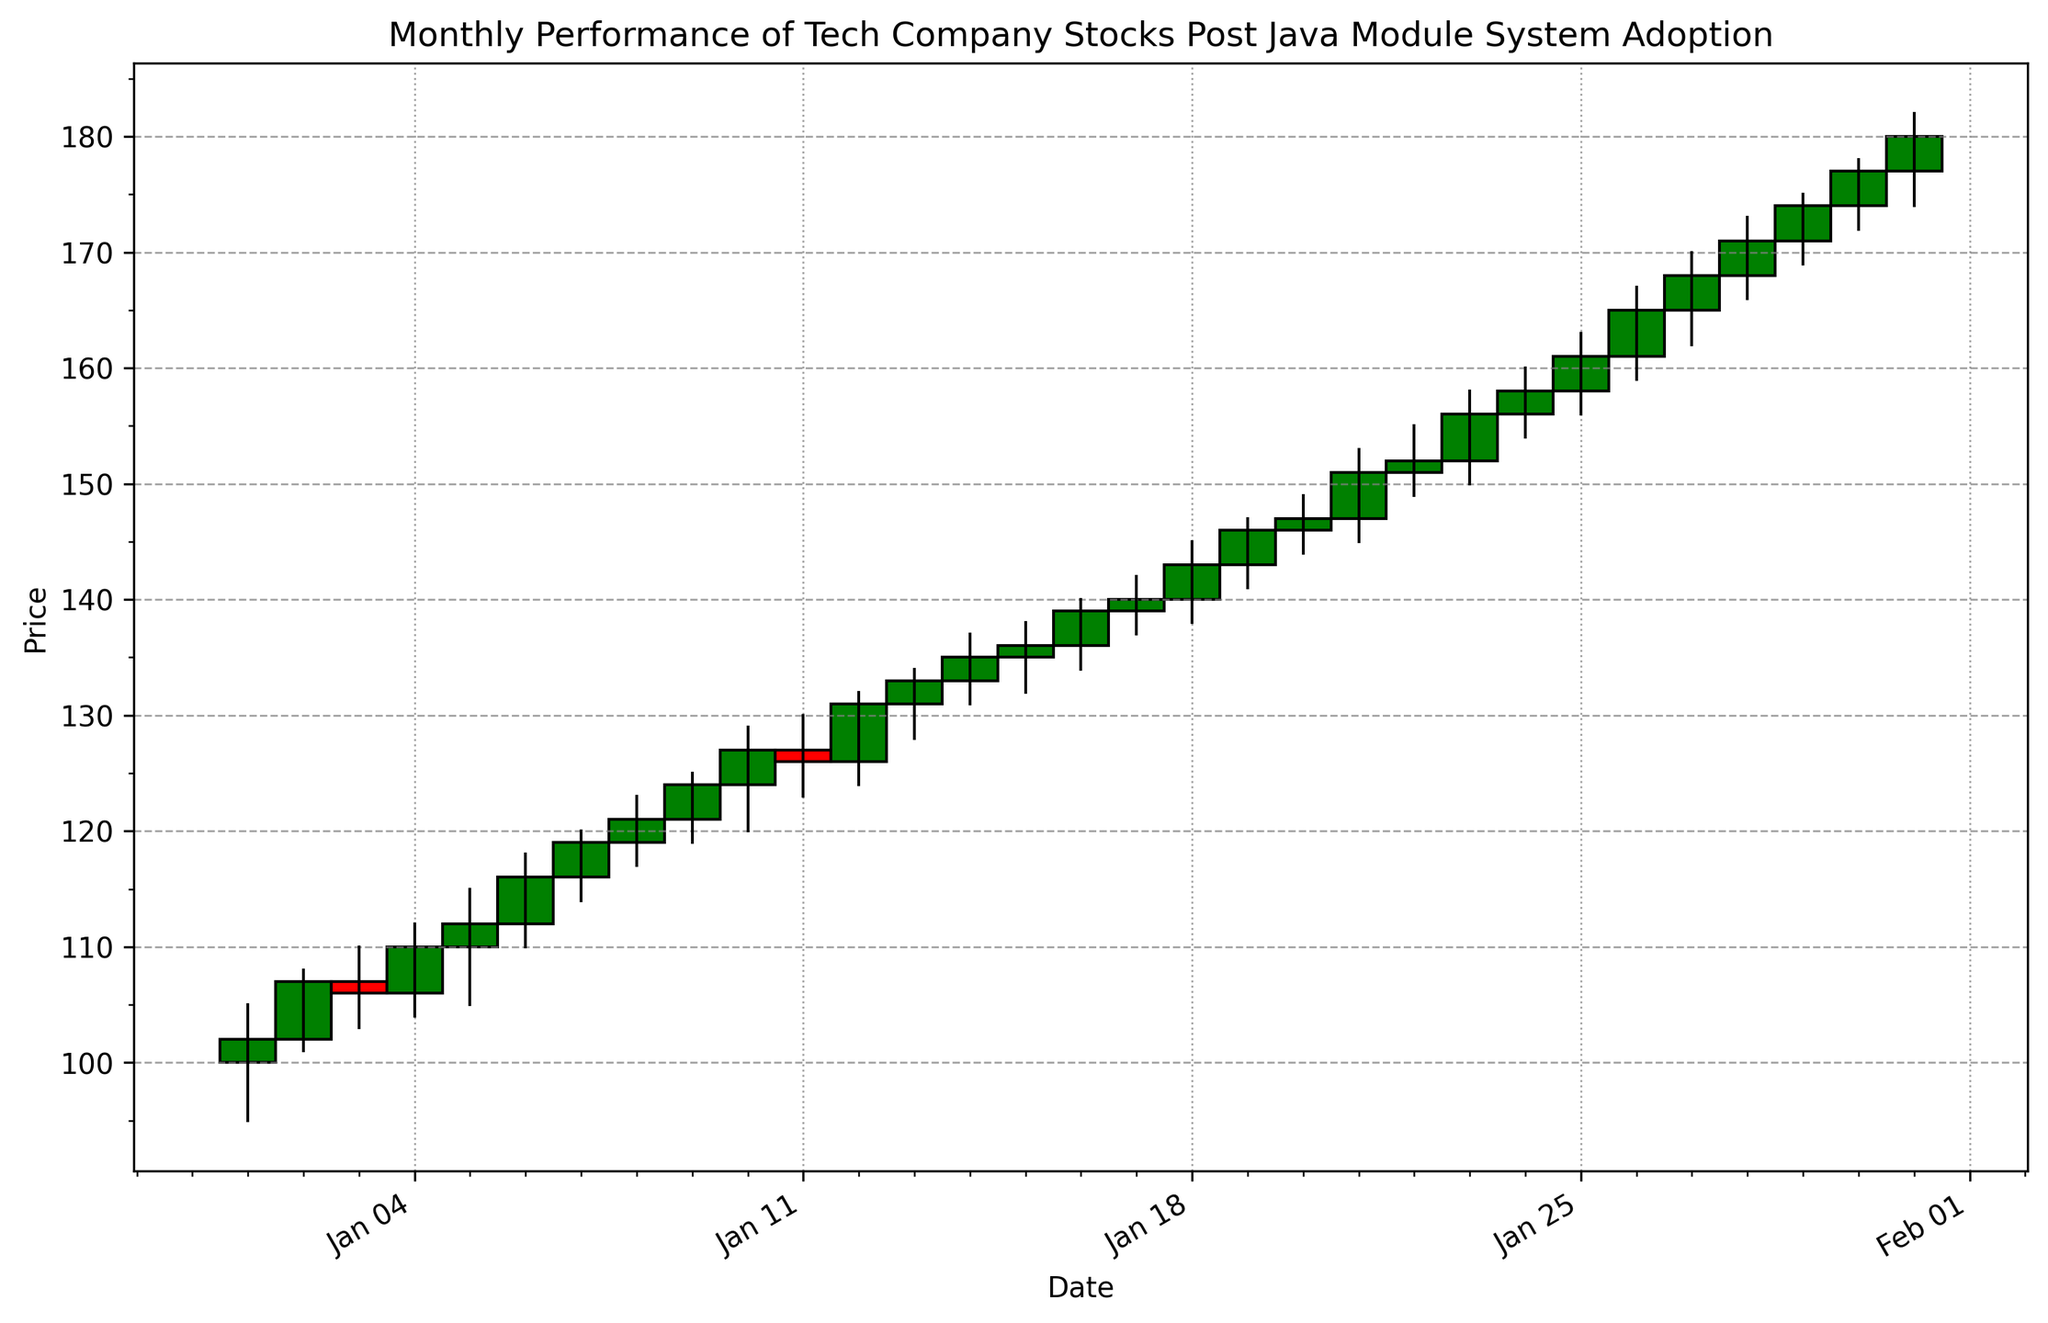What is the closing price on January 15th? Locate the candlestick corresponding to January 15th. The top of the candlestick's colored rectangle represents the closing price. The rectangle ends at 136.
Answer: 136 Compare the high prices on January 10th and January 20th. Which day had a higher high price? Identify the high points on January 10th and January 20th by looking at the top of the high-low vertical lines of those days. January 20th's high is 149 whereas January 10th's high is 129.
Answer: January 20th Which day had the highest trading volume, and what was that volume? Observe the vertical bars representing trading volumes. The tallest bar corresponds to January 3rd with a volume of 1,500,000.
Answer: January 3rd, 1,500,000 How many days had a closing price higher than 150, and what were those closing prices? Identify days where the candlestick's top is above 150. The days are January 21st, January 23rd, January 24th, January 25th, January 26th, January 27th, January 28th, January 29th, January 30th, and January 31st. The closing prices are 151, 156, 158, 161, 165, 168, 171, 174, 177, and 180 respectively.
Answer: 10 days, closing prices: 151, 156, 158, 161, 165, 168, 171, 174, 177, 180 What were the opening and closing prices on the day with the longest candlestick? The longest candlestick reflects the largest difference between the opening and closing prices. January 26th has the longest candlestick, spanning from an open of 161 to a close of 165.
Answer: Open: 161, Close: 165 Which day marked the highest price point in the month, and what was that high price? Scan the highest points on the vertical lines of the high-low range. January 31st has the highest point at 182.
Answer: January 31st, 182 What was the color of the candlestick on January 13th and why? The candlestick color representation: green for a close price higher than open, and red otherwise. January 13th is green as the close (133) is higher than the open (131).
Answer: Green, because close > open Between January 5th and January 10th, did the closing price generally trend upward or downward? Observe the closing prices from top of the candlesticks: Jan 5 (112), Jan 6 (116), Jan 7 (119), Jan 8 (121), Jan 9 (124), and Jan 10 (127).
Answer: Upward What is the average closing price between January 15th and January 20th, inclusive? Identify closing prices for Jan 15-20 as: 136, 139, 140, 143, 146, and 147. Calculate the average: (136+139+140+143+146+147)/6 = 141.83
Answer: 141.83 